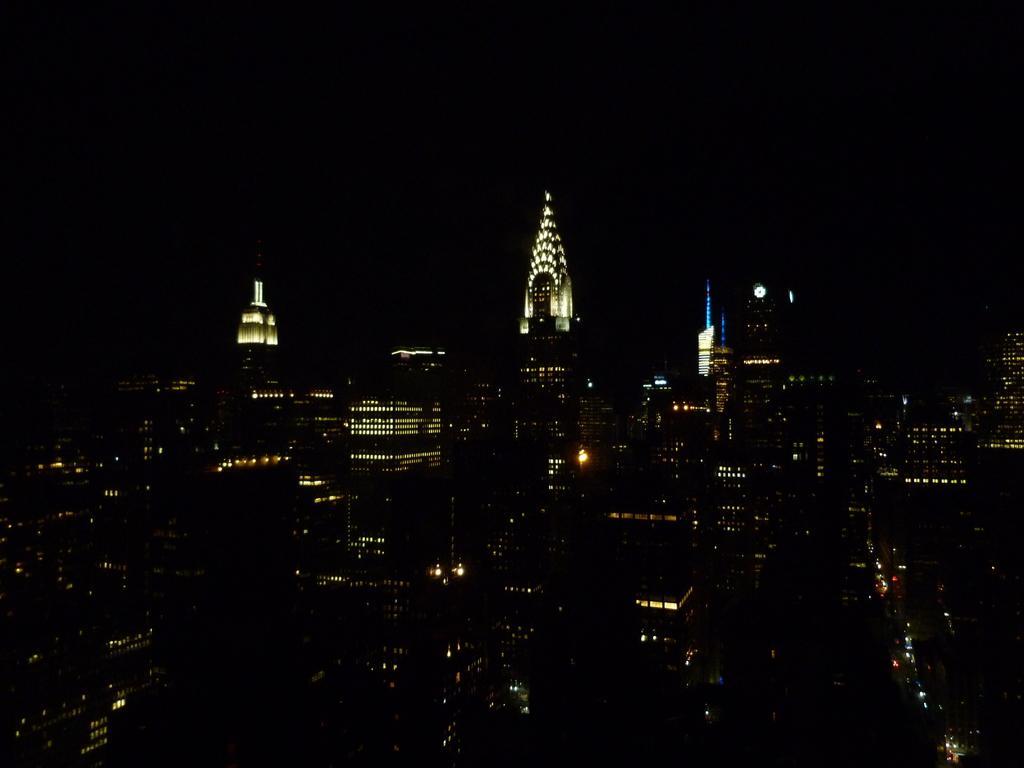In one or two sentences, can you explain what this image depicts? In the foreground of this image, there are buildings and skyscrapers with lights in the dark. 